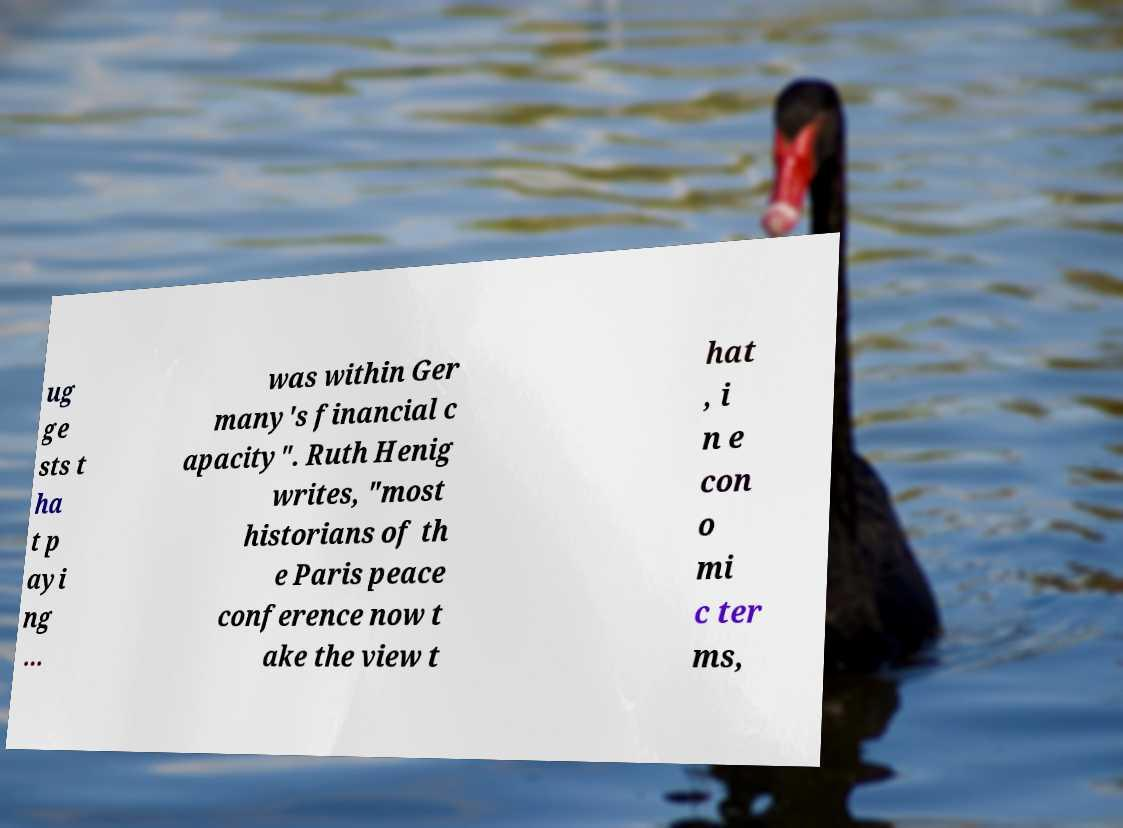I need the written content from this picture converted into text. Can you do that? ug ge sts t ha t p ayi ng ... was within Ger many's financial c apacity". Ruth Henig writes, "most historians of th e Paris peace conference now t ake the view t hat , i n e con o mi c ter ms, 